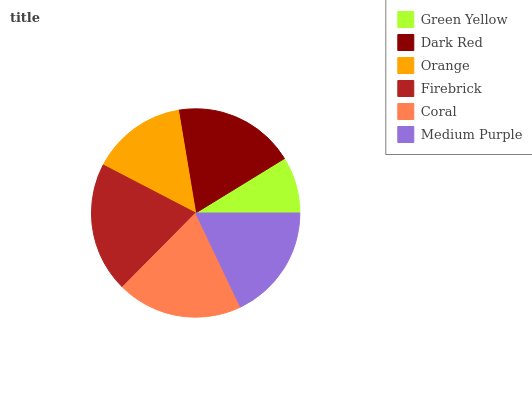Is Green Yellow the minimum?
Answer yes or no. Yes. Is Firebrick the maximum?
Answer yes or no. Yes. Is Dark Red the minimum?
Answer yes or no. No. Is Dark Red the maximum?
Answer yes or no. No. Is Dark Red greater than Green Yellow?
Answer yes or no. Yes. Is Green Yellow less than Dark Red?
Answer yes or no. Yes. Is Green Yellow greater than Dark Red?
Answer yes or no. No. Is Dark Red less than Green Yellow?
Answer yes or no. No. Is Dark Red the high median?
Answer yes or no. Yes. Is Medium Purple the low median?
Answer yes or no. Yes. Is Firebrick the high median?
Answer yes or no. No. Is Dark Red the low median?
Answer yes or no. No. 